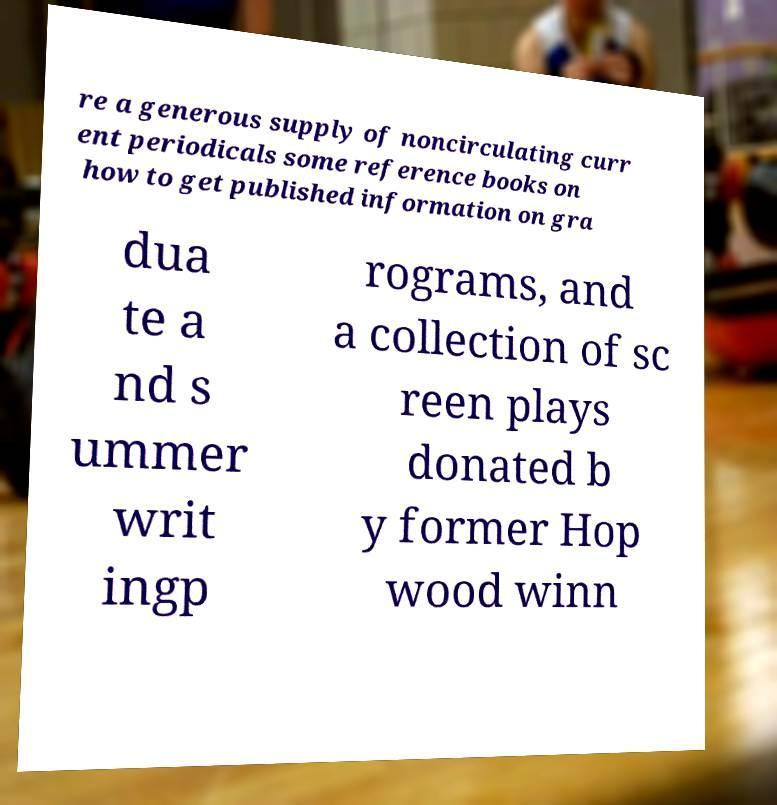Please read and relay the text visible in this image. What does it say? re a generous supply of noncirculating curr ent periodicals some reference books on how to get published information on gra dua te a nd s ummer writ ingp rograms, and a collection of sc reen plays donated b y former Hop wood winn 